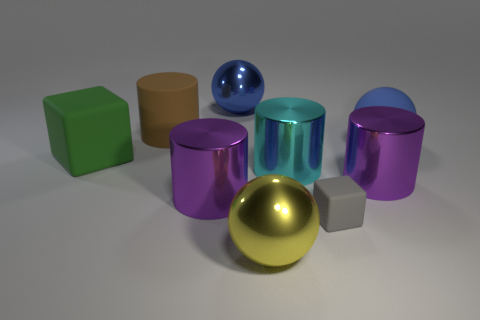Subtract all big metal cylinders. How many cylinders are left? 1 Add 1 tiny gray metal objects. How many objects exist? 10 Subtract all cylinders. How many objects are left? 5 Subtract all green blocks. How many blocks are left? 1 Subtract 1 cubes. How many cubes are left? 1 Subtract all yellow blocks. How many yellow balls are left? 1 Subtract all green things. Subtract all big matte blocks. How many objects are left? 7 Add 4 big blocks. How many big blocks are left? 5 Add 7 gray things. How many gray things exist? 8 Subtract 1 green cubes. How many objects are left? 8 